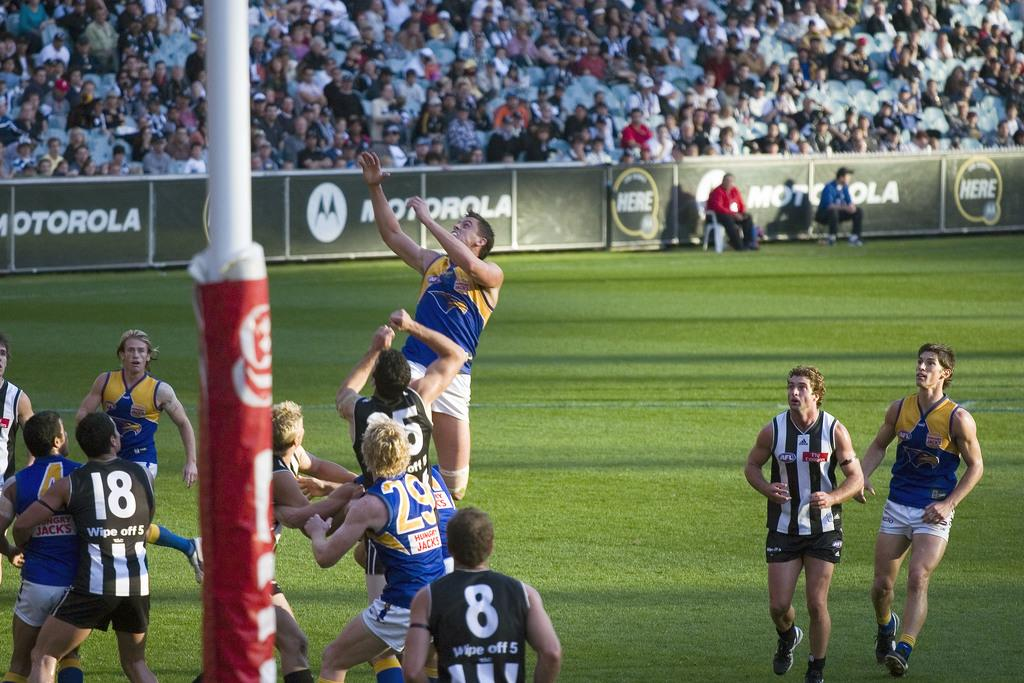<image>
Give a short and clear explanation of the subsequent image. Men play on a rugby field that is sponsored by Motorola. 